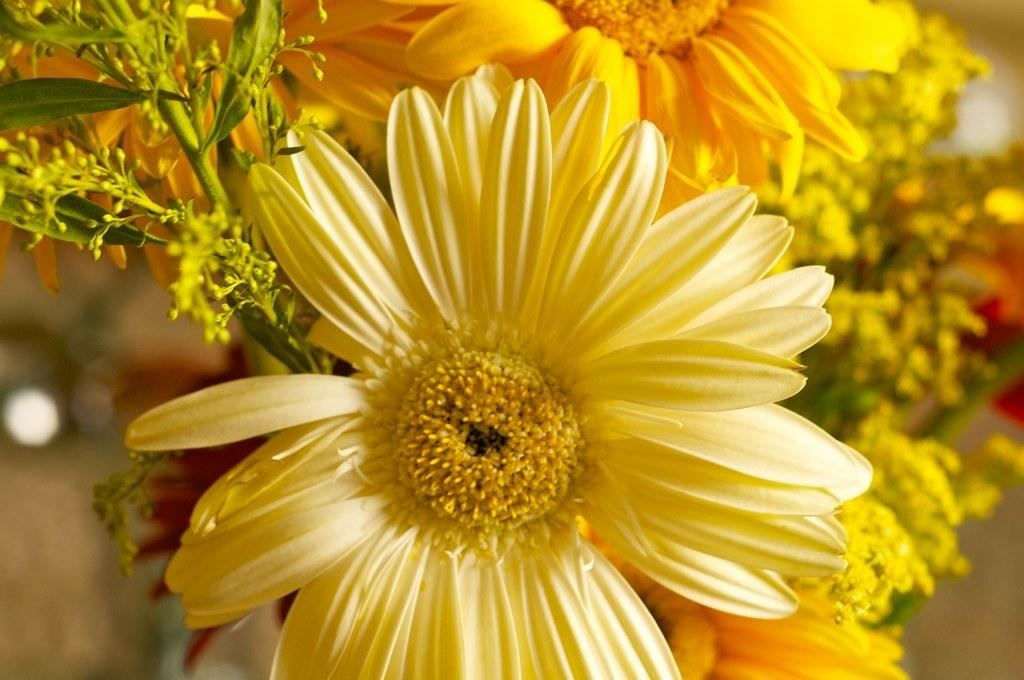What type of plant life is present in the image? There are flowers, stems, and leaves in the image. Can you describe the appearance of the flowers? Unfortunately, the details of the flowers cannot be discerned due to the blurry background of the image. What else can be seen in the image besides the flowers? There are stems and leaves visible in the image. What star was discovered by the flowers in the image? There is no star or discovery mentioned in the image; it only features flowers, stems, and leaves. 